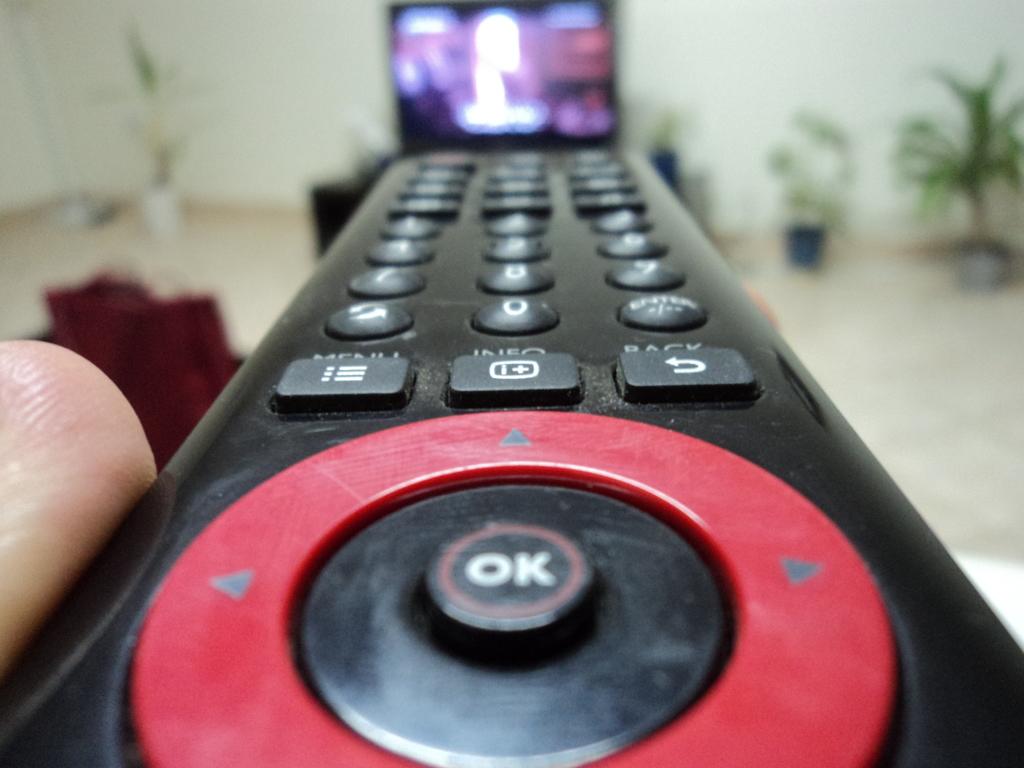What is the button in the middle of the arrows for?
Give a very brief answer. Ok. Is there a back button?
Offer a very short reply. Yes. 